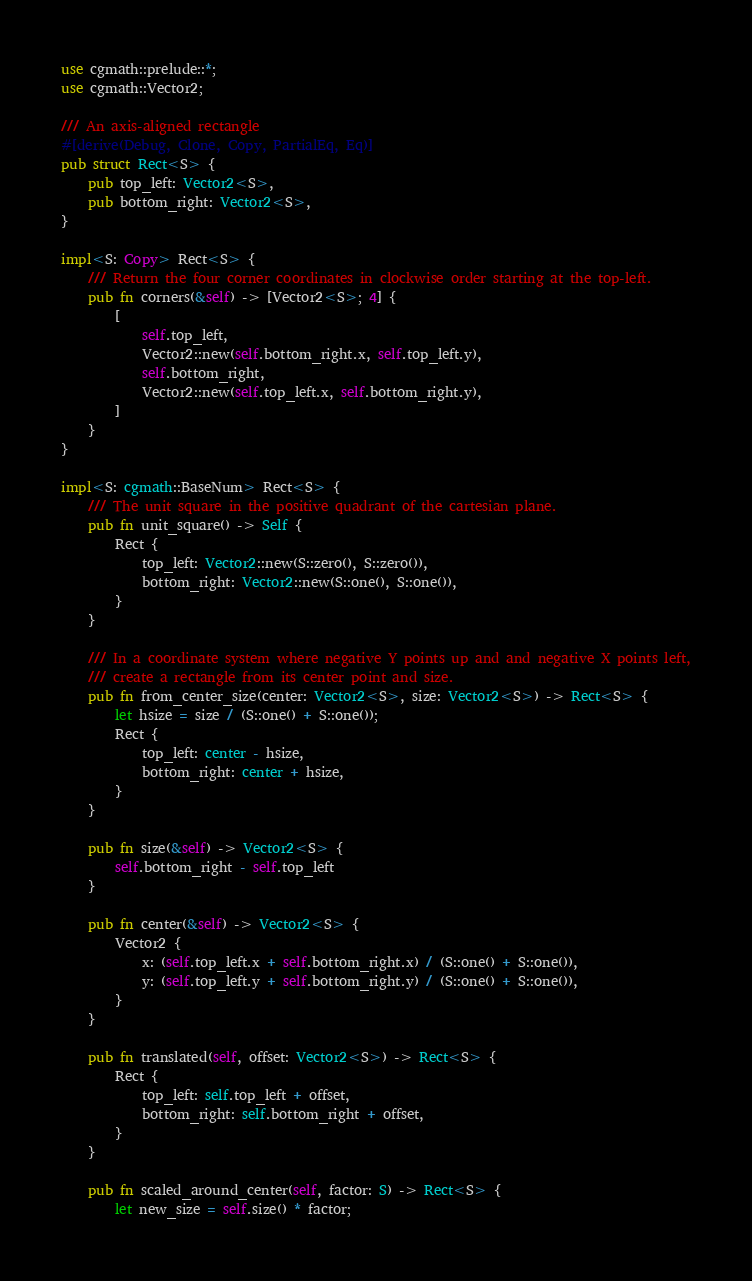<code> <loc_0><loc_0><loc_500><loc_500><_Rust_>use cgmath::prelude::*;
use cgmath::Vector2;

/// An axis-aligned rectangle
#[derive(Debug, Clone, Copy, PartialEq, Eq)]
pub struct Rect<S> {
    pub top_left: Vector2<S>,
    pub bottom_right: Vector2<S>,
}

impl<S: Copy> Rect<S> {
    /// Return the four corner coordinates in clockwise order starting at the top-left.
    pub fn corners(&self) -> [Vector2<S>; 4] {
        [
            self.top_left,
            Vector2::new(self.bottom_right.x, self.top_left.y),
            self.bottom_right,
            Vector2::new(self.top_left.x, self.bottom_right.y),
        ]
    }
}

impl<S: cgmath::BaseNum> Rect<S> {
    /// The unit square in the positive quadrant of the cartesian plane.
    pub fn unit_square() -> Self {
        Rect {
            top_left: Vector2::new(S::zero(), S::zero()),
            bottom_right: Vector2::new(S::one(), S::one()),
        }
    }

    /// In a coordinate system where negative Y points up and and negative X points left,
    /// create a rectangle from its center point and size.
    pub fn from_center_size(center: Vector2<S>, size: Vector2<S>) -> Rect<S> {
        let hsize = size / (S::one() + S::one());
        Rect {
            top_left: center - hsize,
            bottom_right: center + hsize,
        }
    }

    pub fn size(&self) -> Vector2<S> {
        self.bottom_right - self.top_left
    }

    pub fn center(&self) -> Vector2<S> {
        Vector2 {
            x: (self.top_left.x + self.bottom_right.x) / (S::one() + S::one()),
            y: (self.top_left.y + self.bottom_right.y) / (S::one() + S::one()),
        }
    }

    pub fn translated(self, offset: Vector2<S>) -> Rect<S> {
        Rect {
            top_left: self.top_left + offset,
            bottom_right: self.bottom_right + offset,
        }
    }

    pub fn scaled_around_center(self, factor: S) -> Rect<S> {
        let new_size = self.size() * factor;</code> 